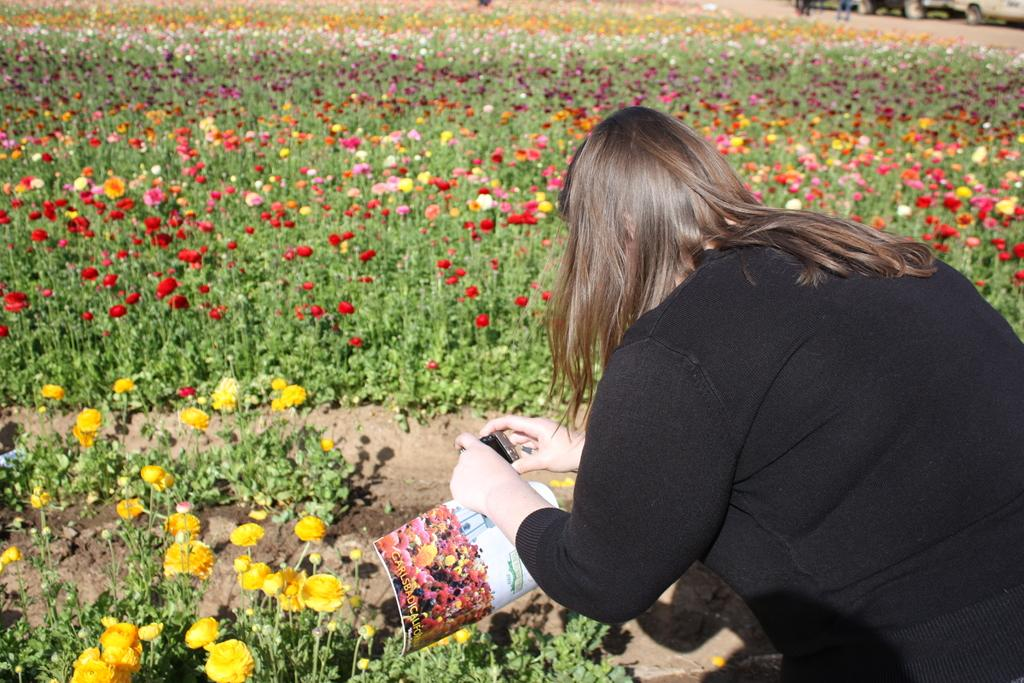Who is in the picture? There is a woman in the picture. What is the woman holding? The woman is holding a camera. What can be seen on the ground in the image? There are plants and flowers on the ground. Is there any indication of a road in the image? Yes, there may be a vehicle present on the road. What type of necklace is the woman wearing in the image? There is no necklace visible in the image; the woman is holding a camera. What kind of lumber is being transported on the road in the image? There is no lumber present in the image; there may be a vehicle on the road, but no specific cargo is mentioned. 